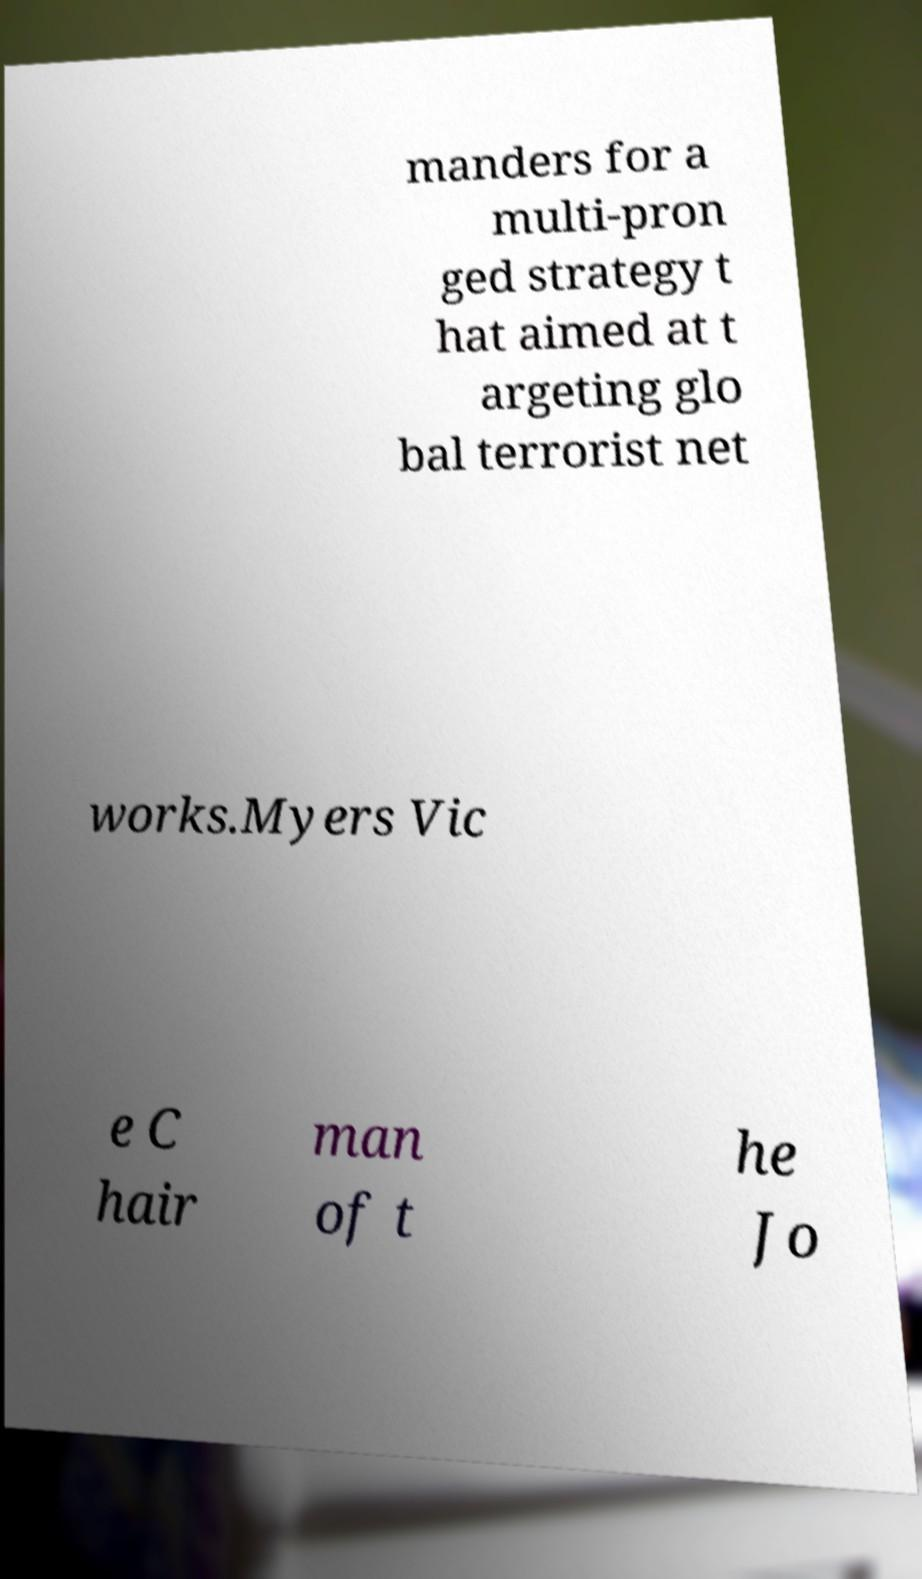Could you extract and type out the text from this image? manders for a multi-pron ged strategy t hat aimed at t argeting glo bal terrorist net works.Myers Vic e C hair man of t he Jo 